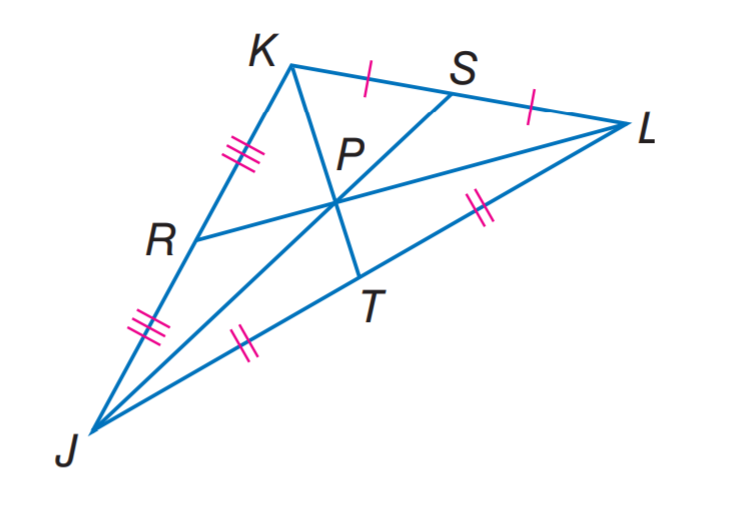Answer the mathemtical geometry problem and directly provide the correct option letter.
Question: In \triangle J K L, P T = 2. Find K P.
Choices: A: 2 B: 4 C: 6 D: 8 B 